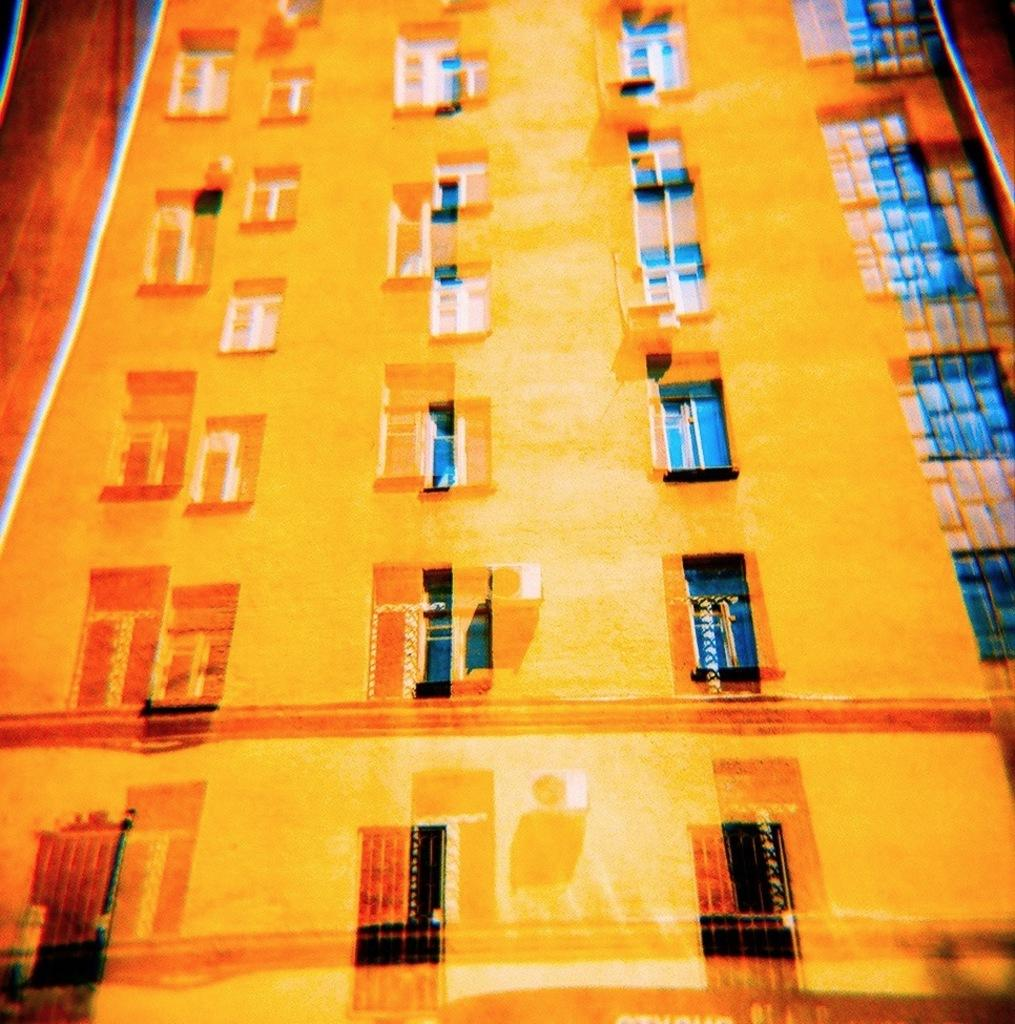What type of image is being described? The image is an edited picture. What can be seen in the image besides the editing? There is a building in the image. Are there any specific features of the building visible in the image? The image shows curtains behind the window of the building. What type of pets can be seen playing with a flag on a sofa in the image? There are no pets, flags, or sofas present in the image; it only features an edited picture of a building with curtains behind the window. 